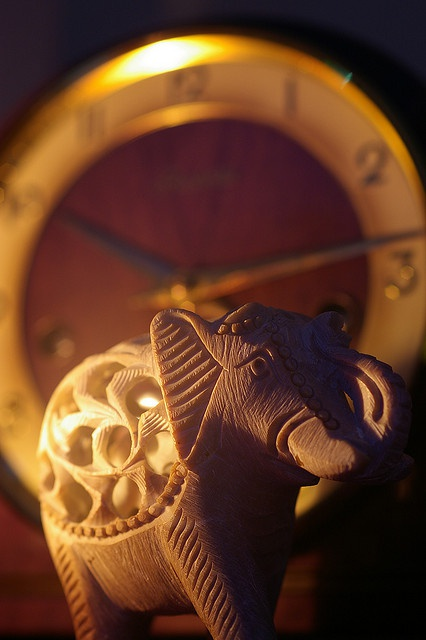Describe the objects in this image and their specific colors. I can see a clock in black, maroon, brown, and orange tones in this image. 